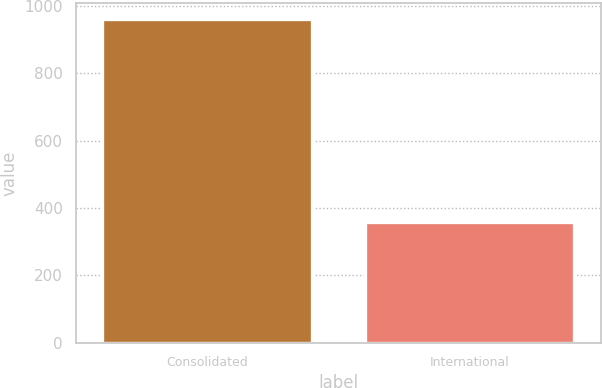Convert chart. <chart><loc_0><loc_0><loc_500><loc_500><bar_chart><fcel>Consolidated<fcel>International<nl><fcel>960.2<fcel>359<nl></chart> 